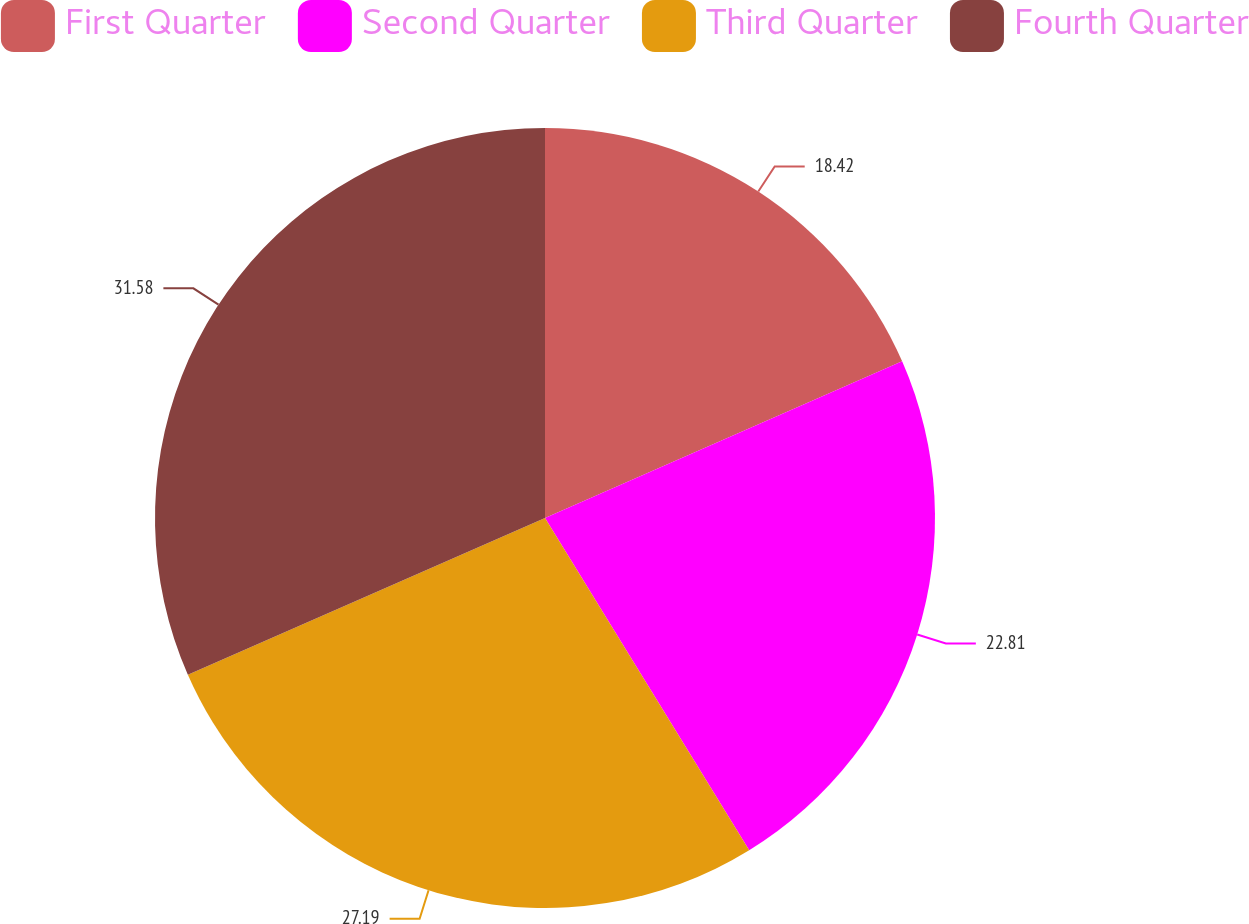Convert chart to OTSL. <chart><loc_0><loc_0><loc_500><loc_500><pie_chart><fcel>First Quarter<fcel>Second Quarter<fcel>Third Quarter<fcel>Fourth Quarter<nl><fcel>18.42%<fcel>22.81%<fcel>27.19%<fcel>31.58%<nl></chart> 